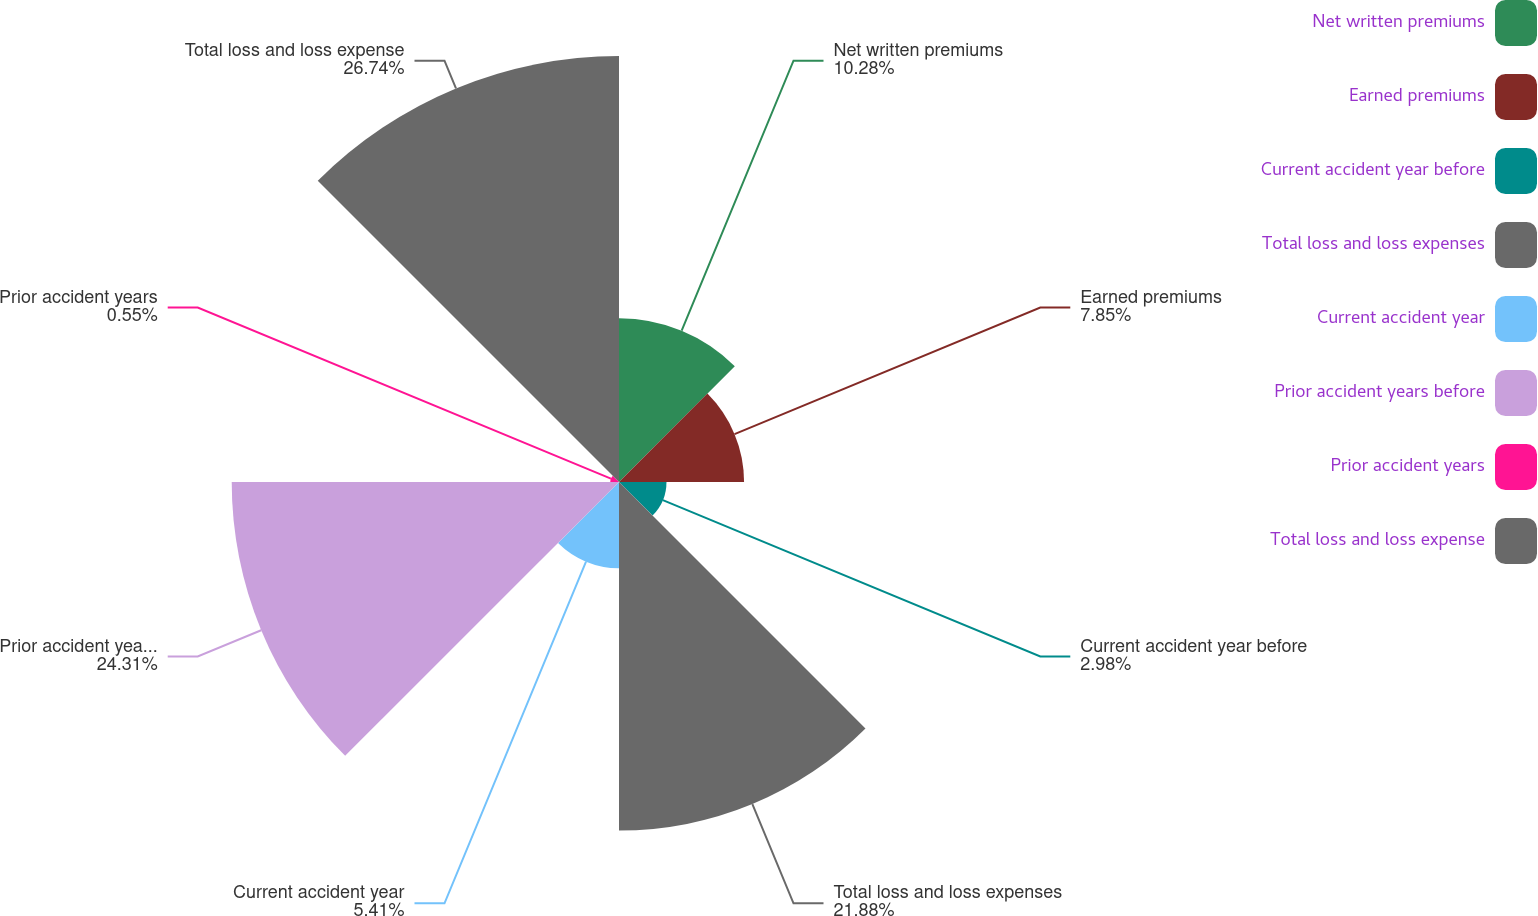<chart> <loc_0><loc_0><loc_500><loc_500><pie_chart><fcel>Net written premiums<fcel>Earned premiums<fcel>Current accident year before<fcel>Total loss and loss expenses<fcel>Current accident year<fcel>Prior accident years before<fcel>Prior accident years<fcel>Total loss and loss expense<nl><fcel>10.28%<fcel>7.85%<fcel>2.98%<fcel>21.88%<fcel>5.41%<fcel>24.31%<fcel>0.55%<fcel>26.74%<nl></chart> 